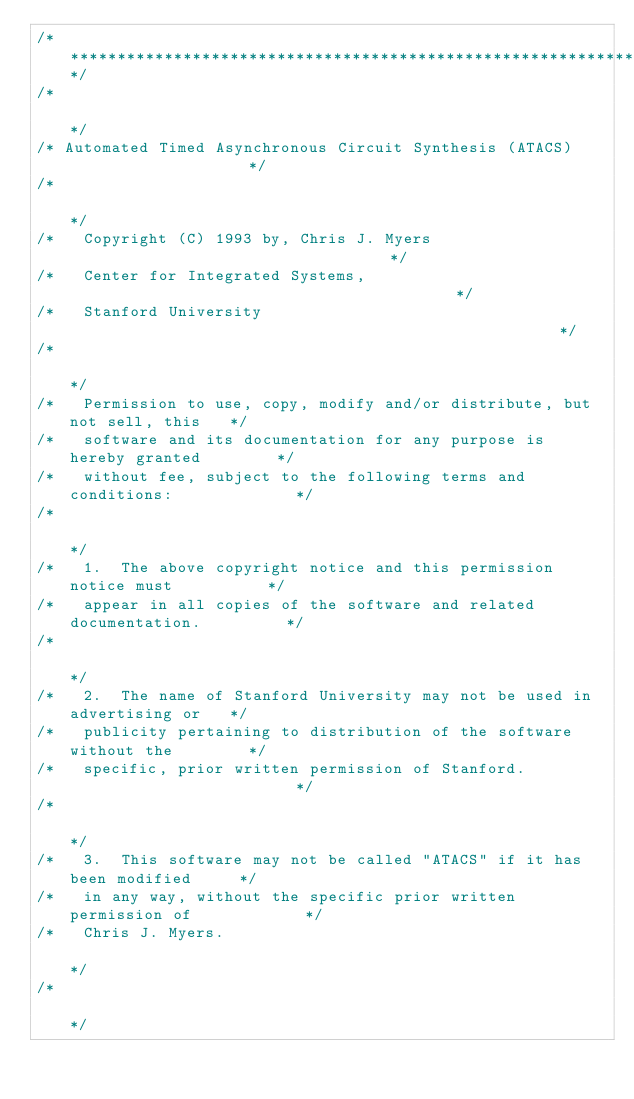Convert code to text. <code><loc_0><loc_0><loc_500><loc_500><_C_>/*****************************************************************************/
/*                                                                           */
/* Automated Timed Asynchronous Circuit Synthesis (ATACS)                    */
/*                                                                           */
/*   Copyright (C) 1993 by, Chris J. Myers                                   */
/*   Center for Integrated Systems,                                          */
/*   Stanford University                                                     */
/*                                                                           */
/*   Permission to use, copy, modify and/or distribute, but not sell, this   */
/*   software and its documentation for any purpose is hereby granted        */
/*   without fee, subject to the following terms and conditions:             */
/*                                                                           */
/*   1.  The above copyright notice and this permission notice must          */
/*   appear in all copies of the software and related documentation.         */
/*                                                                           */
/*   2.  The name of Stanford University may not be used in advertising or   */
/*   publicity pertaining to distribution of the software without the        */
/*   specific, prior written permission of Stanford.                         */
/*                                                                           */
/*   3.  This software may not be called "ATACS" if it has been modified     */
/*   in any way, without the specific prior written permission of            */
/*   Chris J. Myers.                                                         */
/*                                                                           */</code> 